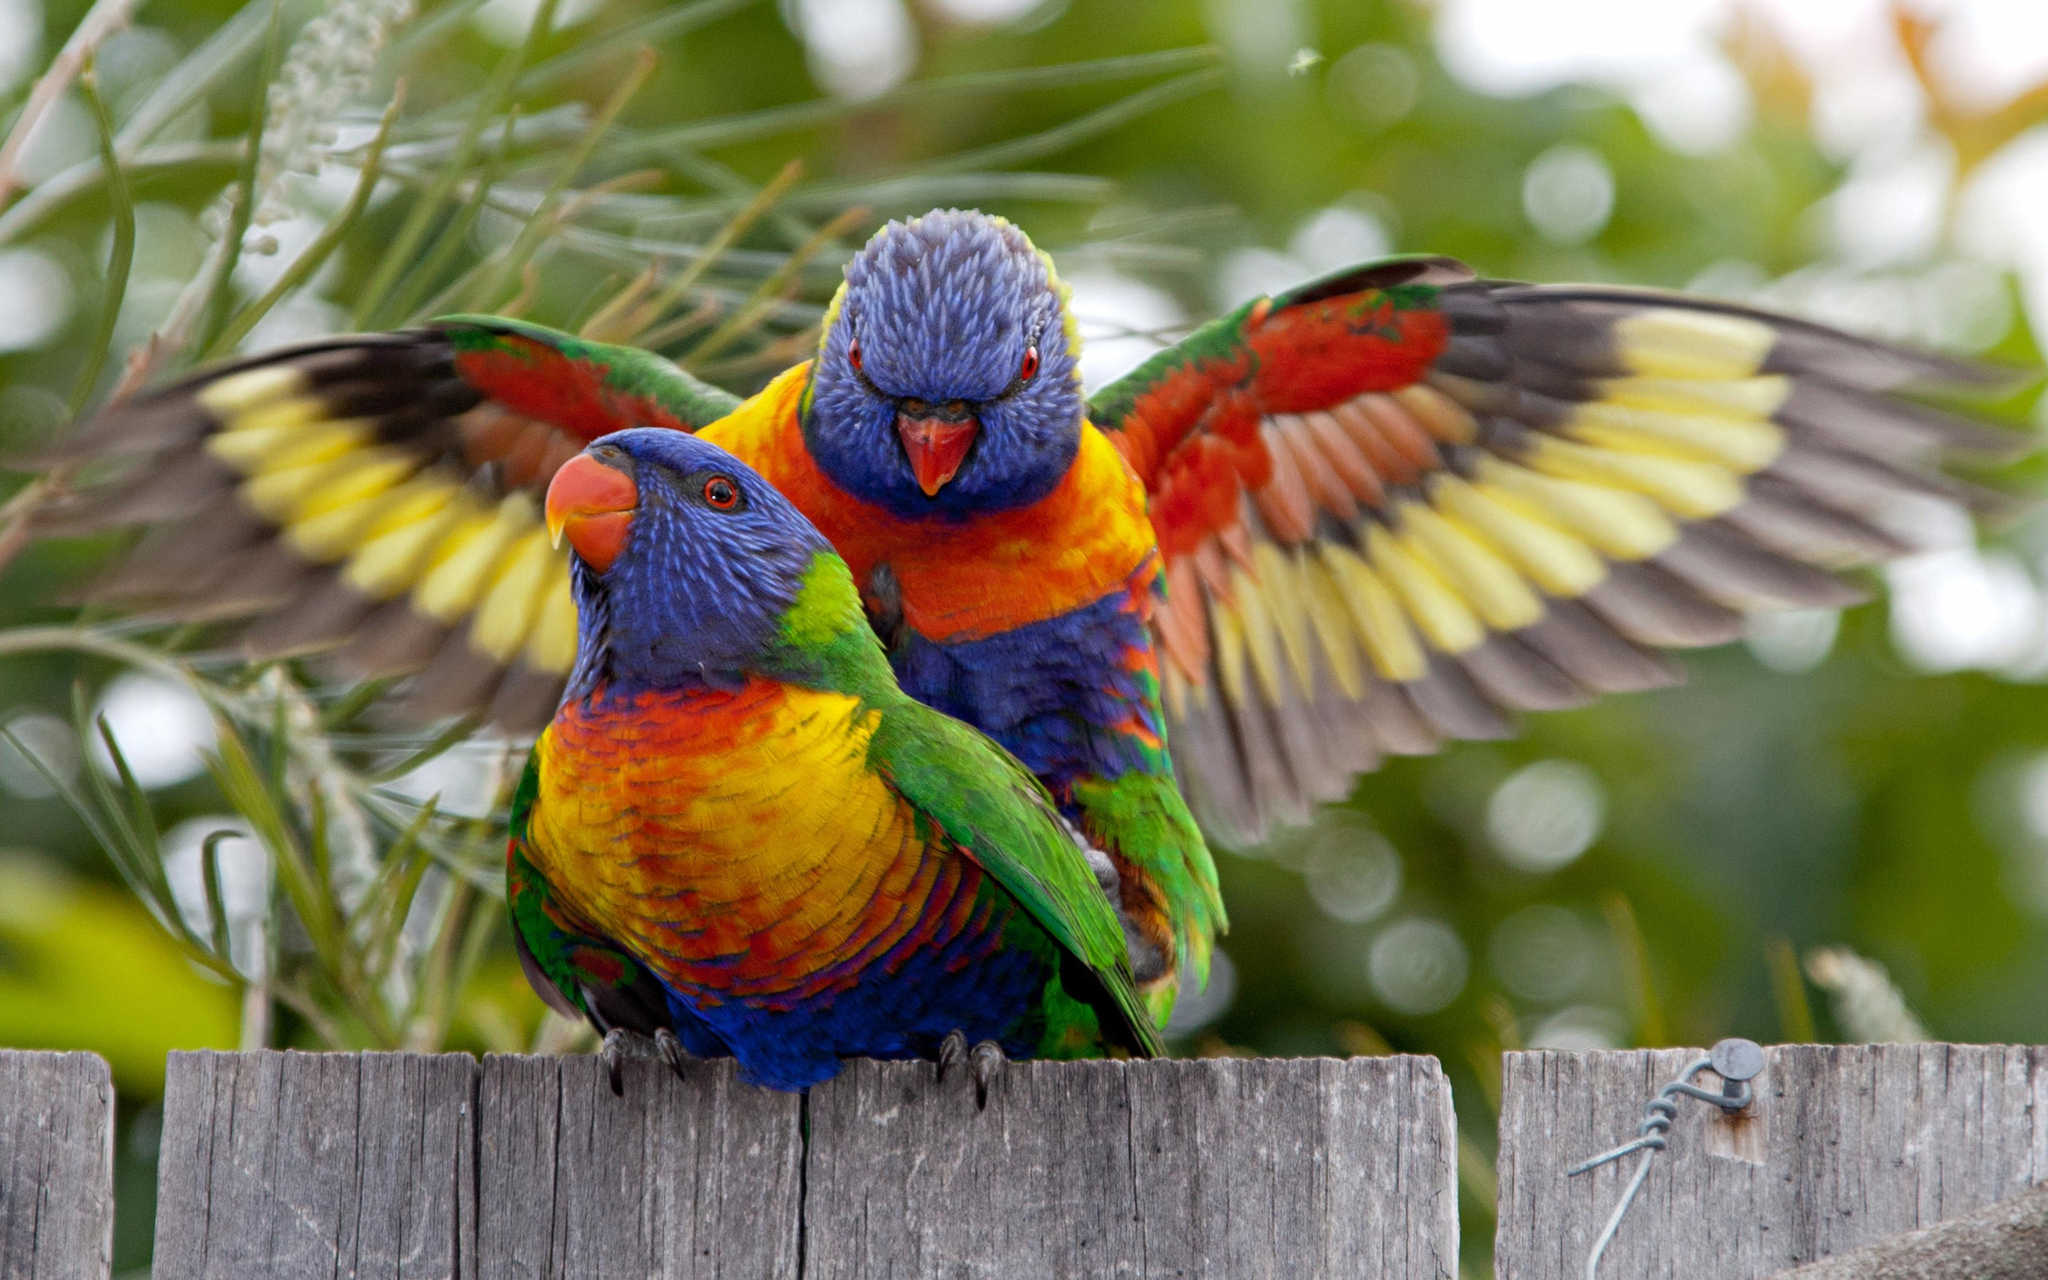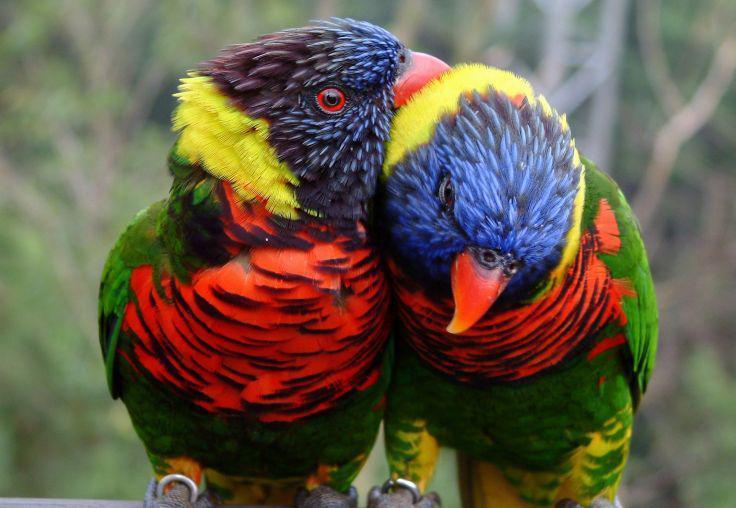The first image is the image on the left, the second image is the image on the right. Evaluate the accuracy of this statement regarding the images: "One image includes a colorful parrot with wide-spread wings.". Is it true? Answer yes or no. Yes. The first image is the image on the left, the second image is the image on the right. For the images displayed, is the sentence "One photo shows a colorful bird with its wings spread" factually correct? Answer yes or no. Yes. 